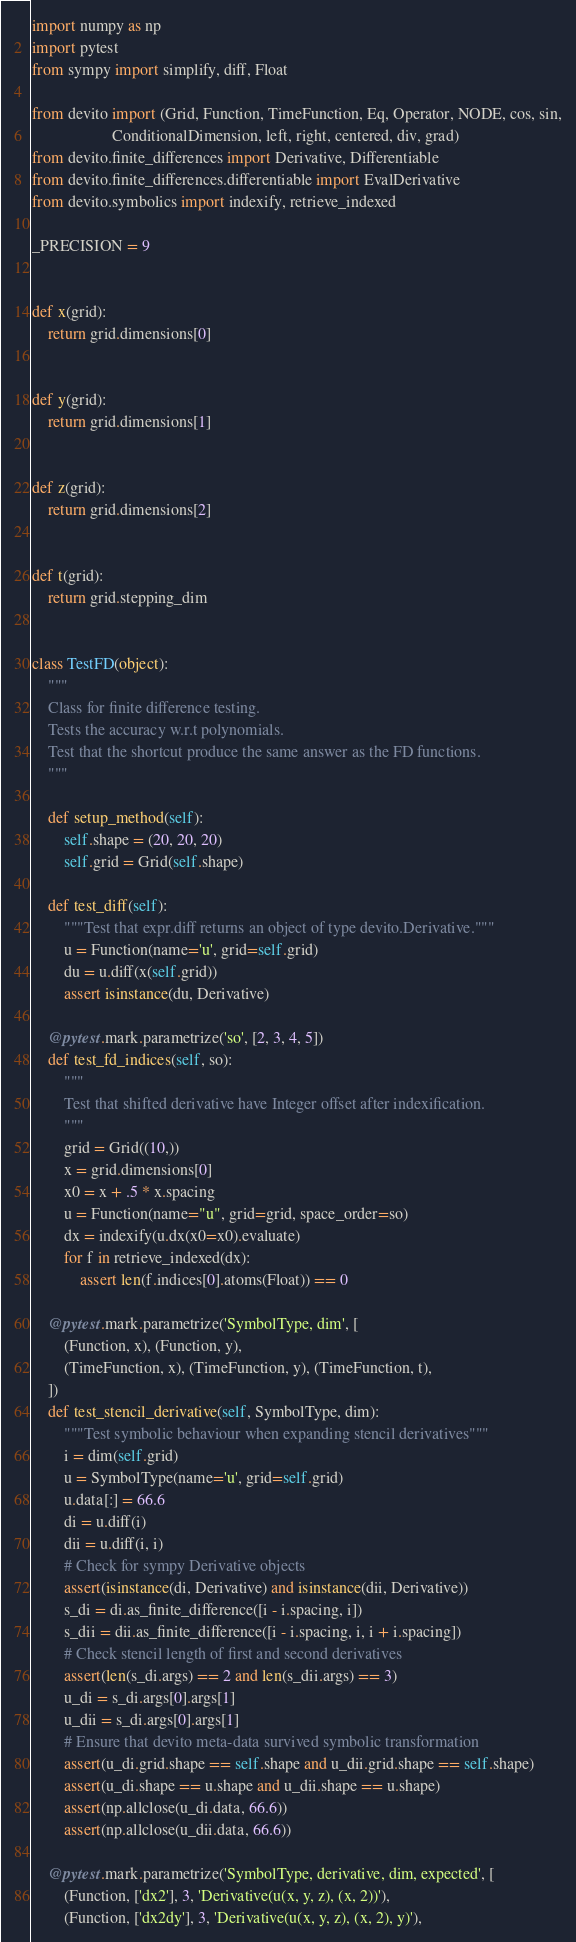<code> <loc_0><loc_0><loc_500><loc_500><_Python_>import numpy as np
import pytest
from sympy import simplify, diff, Float

from devito import (Grid, Function, TimeFunction, Eq, Operator, NODE, cos, sin,
                    ConditionalDimension, left, right, centered, div, grad)
from devito.finite_differences import Derivative, Differentiable
from devito.finite_differences.differentiable import EvalDerivative
from devito.symbolics import indexify, retrieve_indexed

_PRECISION = 9


def x(grid):
    return grid.dimensions[0]


def y(grid):
    return grid.dimensions[1]


def z(grid):
    return grid.dimensions[2]


def t(grid):
    return grid.stepping_dim


class TestFD(object):
    """
    Class for finite difference testing.
    Tests the accuracy w.r.t polynomials.
    Test that the shortcut produce the same answer as the FD functions.
    """

    def setup_method(self):
        self.shape = (20, 20, 20)
        self.grid = Grid(self.shape)

    def test_diff(self):
        """Test that expr.diff returns an object of type devito.Derivative."""
        u = Function(name='u', grid=self.grid)
        du = u.diff(x(self.grid))
        assert isinstance(du, Derivative)

    @pytest.mark.parametrize('so', [2, 3, 4, 5])
    def test_fd_indices(self, so):
        """
        Test that shifted derivative have Integer offset after indexification.
        """
        grid = Grid((10,))
        x = grid.dimensions[0]
        x0 = x + .5 * x.spacing
        u = Function(name="u", grid=grid, space_order=so)
        dx = indexify(u.dx(x0=x0).evaluate)
        for f in retrieve_indexed(dx):
            assert len(f.indices[0].atoms(Float)) == 0

    @pytest.mark.parametrize('SymbolType, dim', [
        (Function, x), (Function, y),
        (TimeFunction, x), (TimeFunction, y), (TimeFunction, t),
    ])
    def test_stencil_derivative(self, SymbolType, dim):
        """Test symbolic behaviour when expanding stencil derivatives"""
        i = dim(self.grid)
        u = SymbolType(name='u', grid=self.grid)
        u.data[:] = 66.6
        di = u.diff(i)
        dii = u.diff(i, i)
        # Check for sympy Derivative objects
        assert(isinstance(di, Derivative) and isinstance(dii, Derivative))
        s_di = di.as_finite_difference([i - i.spacing, i])
        s_dii = dii.as_finite_difference([i - i.spacing, i, i + i.spacing])
        # Check stencil length of first and second derivatives
        assert(len(s_di.args) == 2 and len(s_dii.args) == 3)
        u_di = s_di.args[0].args[1]
        u_dii = s_di.args[0].args[1]
        # Ensure that devito meta-data survived symbolic transformation
        assert(u_di.grid.shape == self.shape and u_dii.grid.shape == self.shape)
        assert(u_di.shape == u.shape and u_dii.shape == u.shape)
        assert(np.allclose(u_di.data, 66.6))
        assert(np.allclose(u_dii.data, 66.6))

    @pytest.mark.parametrize('SymbolType, derivative, dim, expected', [
        (Function, ['dx2'], 3, 'Derivative(u(x, y, z), (x, 2))'),
        (Function, ['dx2dy'], 3, 'Derivative(u(x, y, z), (x, 2), y)'),</code> 